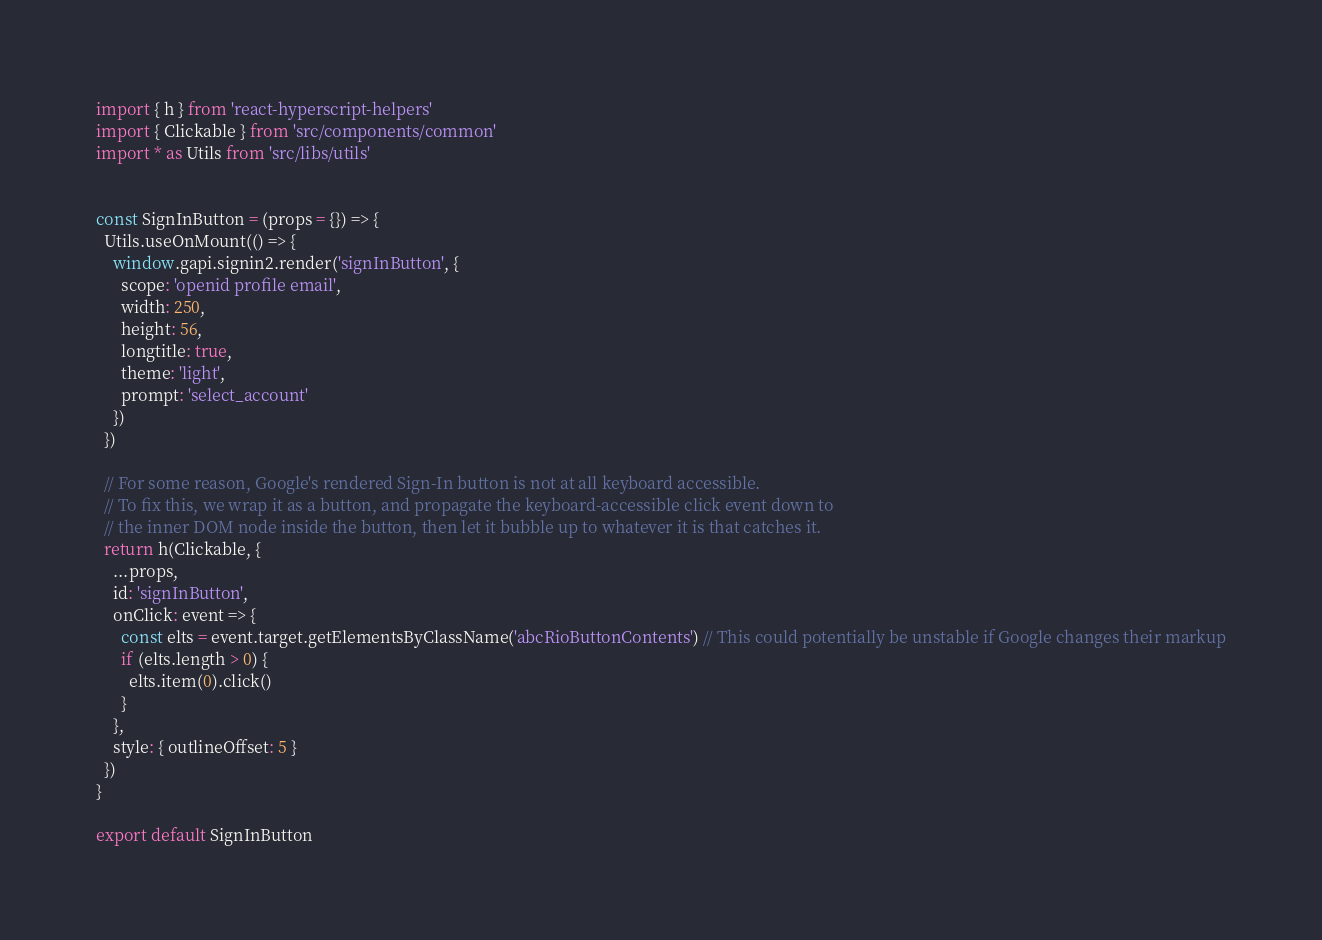Convert code to text. <code><loc_0><loc_0><loc_500><loc_500><_JavaScript_>import { h } from 'react-hyperscript-helpers'
import { Clickable } from 'src/components/common'
import * as Utils from 'src/libs/utils'


const SignInButton = (props = {}) => {
  Utils.useOnMount(() => {
    window.gapi.signin2.render('signInButton', {
      scope: 'openid profile email',
      width: 250,
      height: 56,
      longtitle: true,
      theme: 'light',
      prompt: 'select_account'
    })
  })

  // For some reason, Google's rendered Sign-In button is not at all keyboard accessible.
  // To fix this, we wrap it as a button, and propagate the keyboard-accessible click event down to
  // the inner DOM node inside the button, then let it bubble up to whatever it is that catches it.
  return h(Clickable, {
    ...props,
    id: 'signInButton',
    onClick: event => {
      const elts = event.target.getElementsByClassName('abcRioButtonContents') // This could potentially be unstable if Google changes their markup
      if (elts.length > 0) {
        elts.item(0).click()
      }
    },
    style: { outlineOffset: 5 }
  })
}

export default SignInButton
</code> 